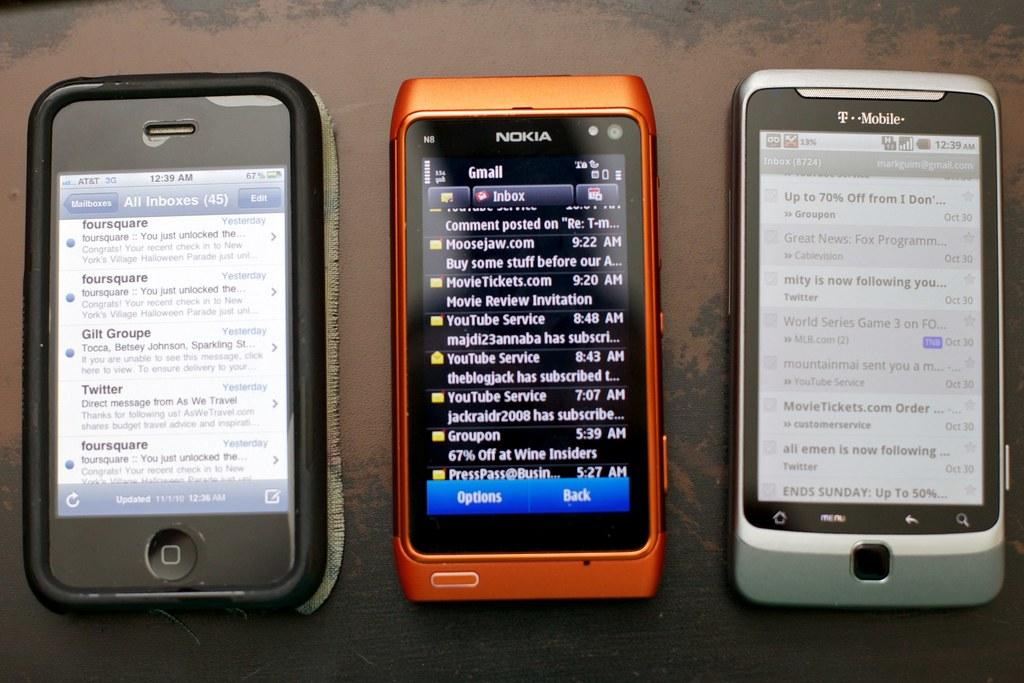Provide a one-sentence caption for the provided image. Three devices sit in a row one by Nokia and another by T-mobile. 